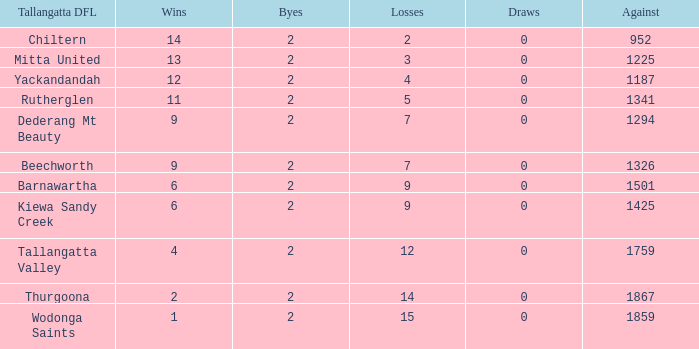What are the draws when wins are fwewer than 9 and byes fewer than 2? 0.0. 